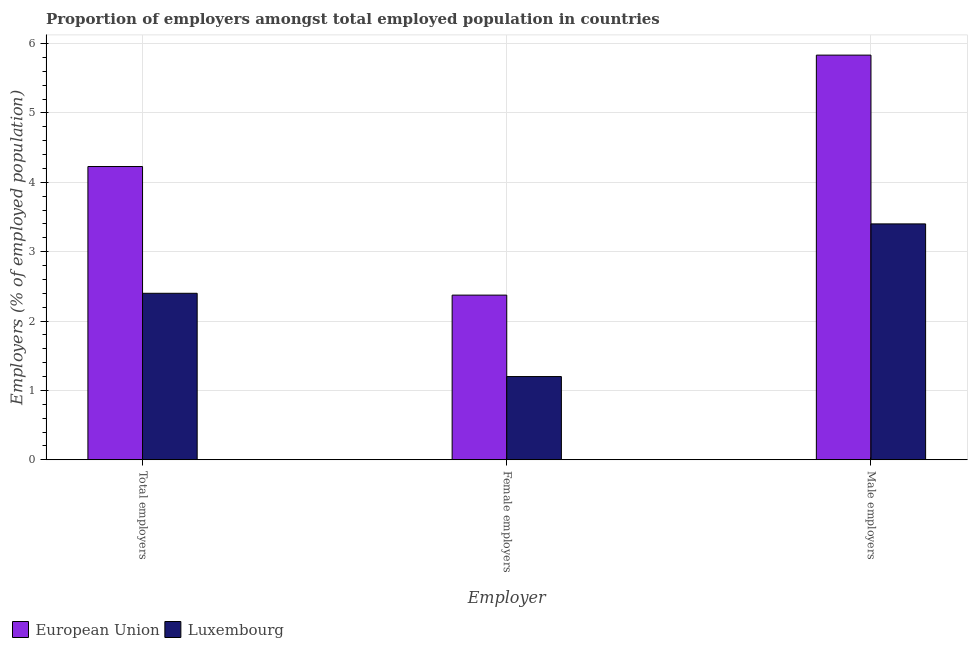How many different coloured bars are there?
Give a very brief answer. 2. How many groups of bars are there?
Your answer should be very brief. 3. Are the number of bars on each tick of the X-axis equal?
Give a very brief answer. Yes. How many bars are there on the 2nd tick from the left?
Offer a terse response. 2. What is the label of the 2nd group of bars from the left?
Keep it short and to the point. Female employers. What is the percentage of female employers in European Union?
Provide a succinct answer. 2.37. Across all countries, what is the maximum percentage of female employers?
Your answer should be very brief. 2.37. Across all countries, what is the minimum percentage of total employers?
Offer a very short reply. 2.4. In which country was the percentage of female employers minimum?
Your response must be concise. Luxembourg. What is the total percentage of male employers in the graph?
Your answer should be very brief. 9.23. What is the difference between the percentage of female employers in Luxembourg and that in European Union?
Keep it short and to the point. -1.17. What is the difference between the percentage of female employers in European Union and the percentage of total employers in Luxembourg?
Make the answer very short. -0.03. What is the average percentage of total employers per country?
Your answer should be compact. 3.31. What is the difference between the percentage of total employers and percentage of female employers in Luxembourg?
Offer a very short reply. 1.2. What is the ratio of the percentage of total employers in European Union to that in Luxembourg?
Your answer should be compact. 1.76. Is the percentage of male employers in European Union less than that in Luxembourg?
Provide a short and direct response. No. Is the difference between the percentage of total employers in Luxembourg and European Union greater than the difference between the percentage of female employers in Luxembourg and European Union?
Offer a very short reply. No. What is the difference between the highest and the second highest percentage of total employers?
Offer a very short reply. 1.83. What is the difference between the highest and the lowest percentage of female employers?
Keep it short and to the point. 1.17. What does the 2nd bar from the left in Total employers represents?
Provide a short and direct response. Luxembourg. What does the 1st bar from the right in Total employers represents?
Your response must be concise. Luxembourg. How many countries are there in the graph?
Ensure brevity in your answer.  2. What is the difference between two consecutive major ticks on the Y-axis?
Your response must be concise. 1. Does the graph contain grids?
Your answer should be very brief. Yes. Where does the legend appear in the graph?
Ensure brevity in your answer.  Bottom left. How many legend labels are there?
Provide a succinct answer. 2. What is the title of the graph?
Make the answer very short. Proportion of employers amongst total employed population in countries. Does "Macedonia" appear as one of the legend labels in the graph?
Your answer should be very brief. No. What is the label or title of the X-axis?
Keep it short and to the point. Employer. What is the label or title of the Y-axis?
Your response must be concise. Employers (% of employed population). What is the Employers (% of employed population) of European Union in Total employers?
Provide a short and direct response. 4.23. What is the Employers (% of employed population) in Luxembourg in Total employers?
Offer a very short reply. 2.4. What is the Employers (% of employed population) of European Union in Female employers?
Keep it short and to the point. 2.37. What is the Employers (% of employed population) of Luxembourg in Female employers?
Your response must be concise. 1.2. What is the Employers (% of employed population) of European Union in Male employers?
Your response must be concise. 5.83. What is the Employers (% of employed population) of Luxembourg in Male employers?
Your response must be concise. 3.4. Across all Employer, what is the maximum Employers (% of employed population) of European Union?
Your answer should be very brief. 5.83. Across all Employer, what is the maximum Employers (% of employed population) in Luxembourg?
Your answer should be very brief. 3.4. Across all Employer, what is the minimum Employers (% of employed population) of European Union?
Provide a short and direct response. 2.37. Across all Employer, what is the minimum Employers (% of employed population) of Luxembourg?
Your answer should be compact. 1.2. What is the total Employers (% of employed population) in European Union in the graph?
Keep it short and to the point. 12.43. What is the difference between the Employers (% of employed population) in European Union in Total employers and that in Female employers?
Offer a very short reply. 1.85. What is the difference between the Employers (% of employed population) of Luxembourg in Total employers and that in Female employers?
Your answer should be compact. 1.2. What is the difference between the Employers (% of employed population) of European Union in Total employers and that in Male employers?
Make the answer very short. -1.61. What is the difference between the Employers (% of employed population) in European Union in Female employers and that in Male employers?
Your answer should be very brief. -3.46. What is the difference between the Employers (% of employed population) of European Union in Total employers and the Employers (% of employed population) of Luxembourg in Female employers?
Provide a succinct answer. 3.03. What is the difference between the Employers (% of employed population) in European Union in Total employers and the Employers (% of employed population) in Luxembourg in Male employers?
Offer a very short reply. 0.83. What is the difference between the Employers (% of employed population) in European Union in Female employers and the Employers (% of employed population) in Luxembourg in Male employers?
Offer a very short reply. -1.03. What is the average Employers (% of employed population) of European Union per Employer?
Ensure brevity in your answer.  4.14. What is the average Employers (% of employed population) in Luxembourg per Employer?
Your answer should be very brief. 2.33. What is the difference between the Employers (% of employed population) of European Union and Employers (% of employed population) of Luxembourg in Total employers?
Provide a succinct answer. 1.83. What is the difference between the Employers (% of employed population) in European Union and Employers (% of employed population) in Luxembourg in Female employers?
Provide a short and direct response. 1.17. What is the difference between the Employers (% of employed population) of European Union and Employers (% of employed population) of Luxembourg in Male employers?
Your answer should be compact. 2.43. What is the ratio of the Employers (% of employed population) of European Union in Total employers to that in Female employers?
Ensure brevity in your answer.  1.78. What is the ratio of the Employers (% of employed population) in Luxembourg in Total employers to that in Female employers?
Give a very brief answer. 2. What is the ratio of the Employers (% of employed population) of European Union in Total employers to that in Male employers?
Make the answer very short. 0.72. What is the ratio of the Employers (% of employed population) in Luxembourg in Total employers to that in Male employers?
Make the answer very short. 0.71. What is the ratio of the Employers (% of employed population) of European Union in Female employers to that in Male employers?
Offer a very short reply. 0.41. What is the ratio of the Employers (% of employed population) of Luxembourg in Female employers to that in Male employers?
Give a very brief answer. 0.35. What is the difference between the highest and the second highest Employers (% of employed population) of European Union?
Your answer should be compact. 1.61. What is the difference between the highest and the lowest Employers (% of employed population) of European Union?
Your answer should be very brief. 3.46. What is the difference between the highest and the lowest Employers (% of employed population) of Luxembourg?
Offer a very short reply. 2.2. 